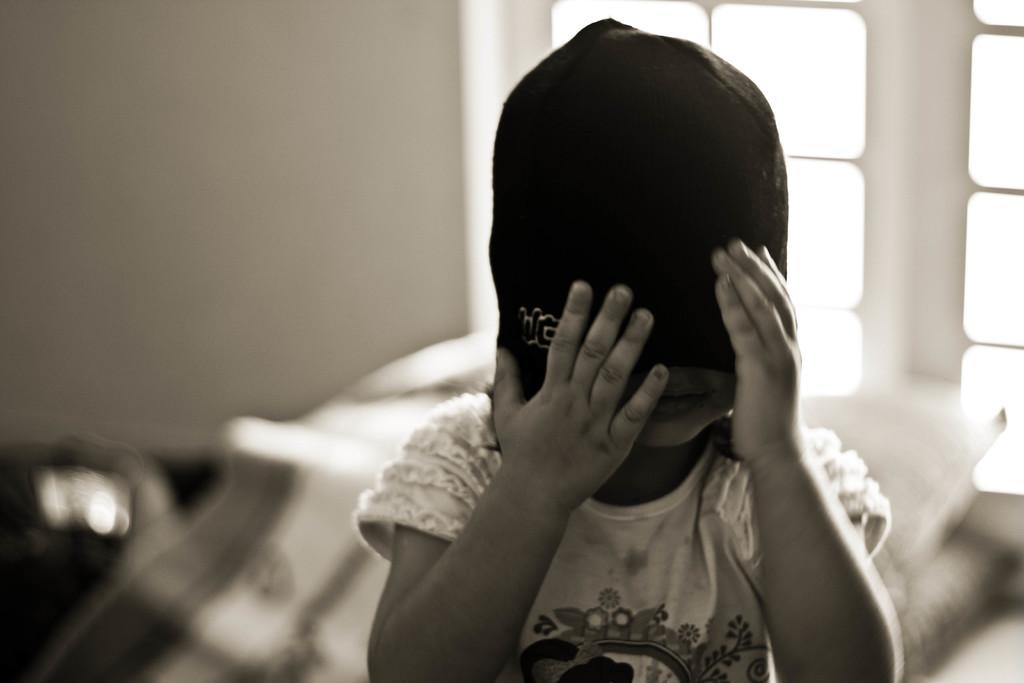What is the main subject of the image? There is a child in the image. What is the child wearing on their head? The child is wearing a cap. Can you describe the background of the image? The background of the image is blurred. What type of coat is the child wearing in the image? There is no coat visible in the image; the child is only wearing a cap. Can you see any space-related objects in the image? There are no space-related objects present in the image. 